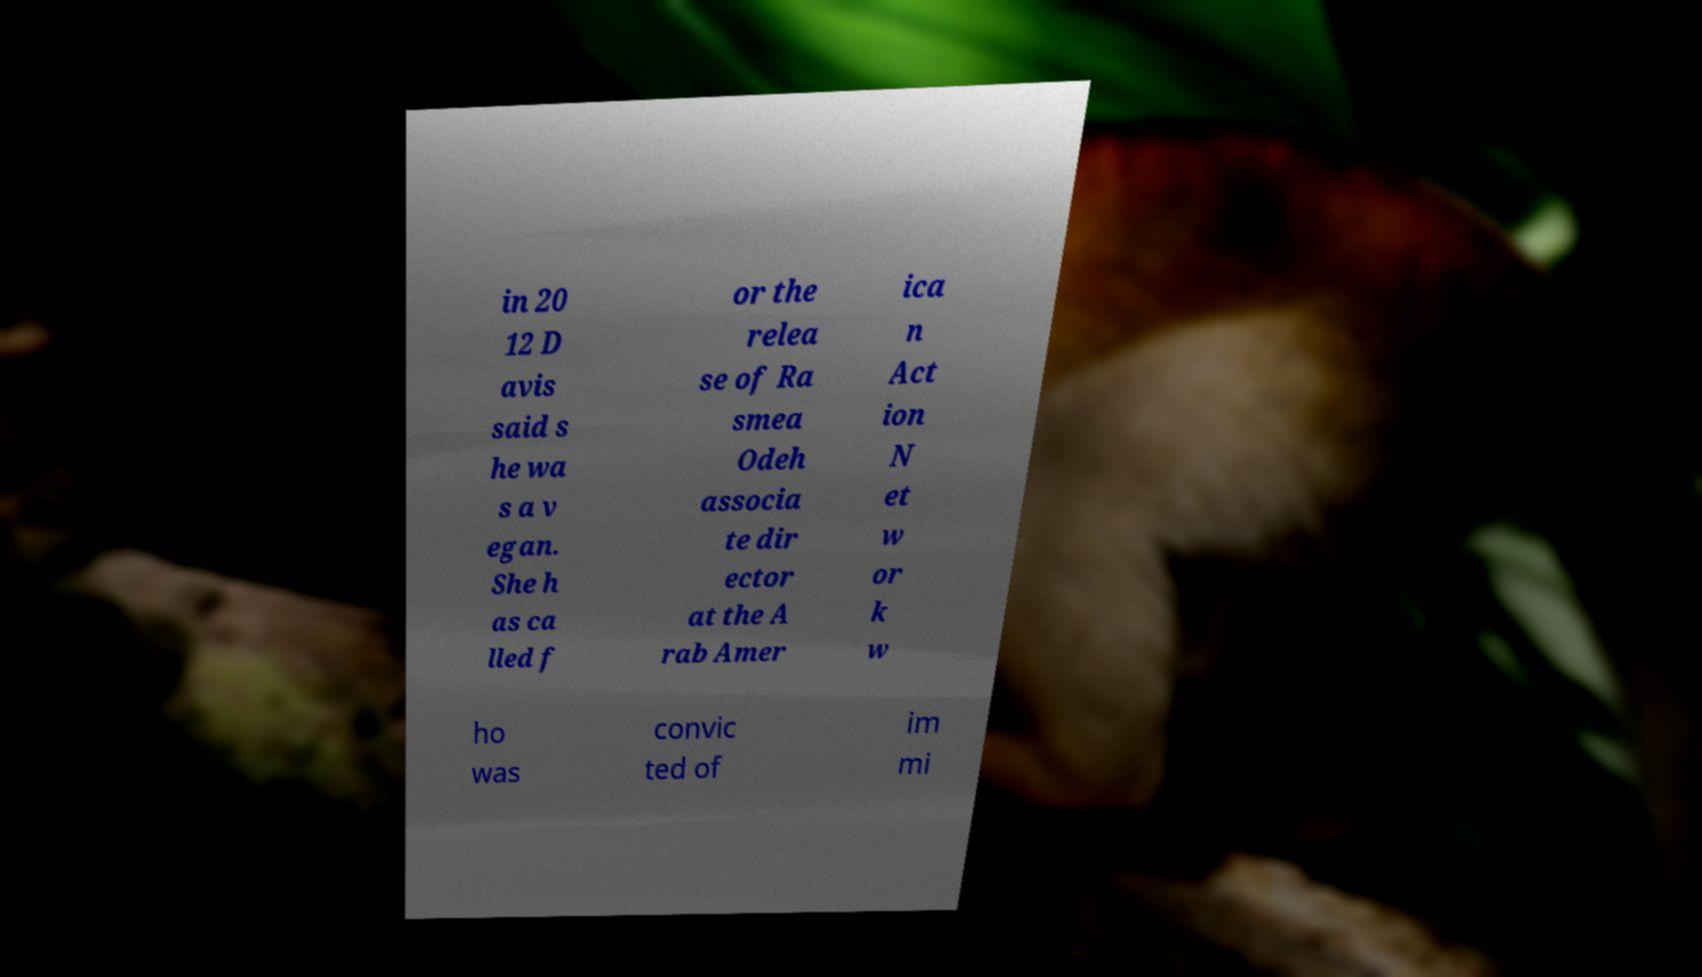Can you read and provide the text displayed in the image?This photo seems to have some interesting text. Can you extract and type it out for me? in 20 12 D avis said s he wa s a v egan. She h as ca lled f or the relea se of Ra smea Odeh associa te dir ector at the A rab Amer ica n Act ion N et w or k w ho was convic ted of im mi 